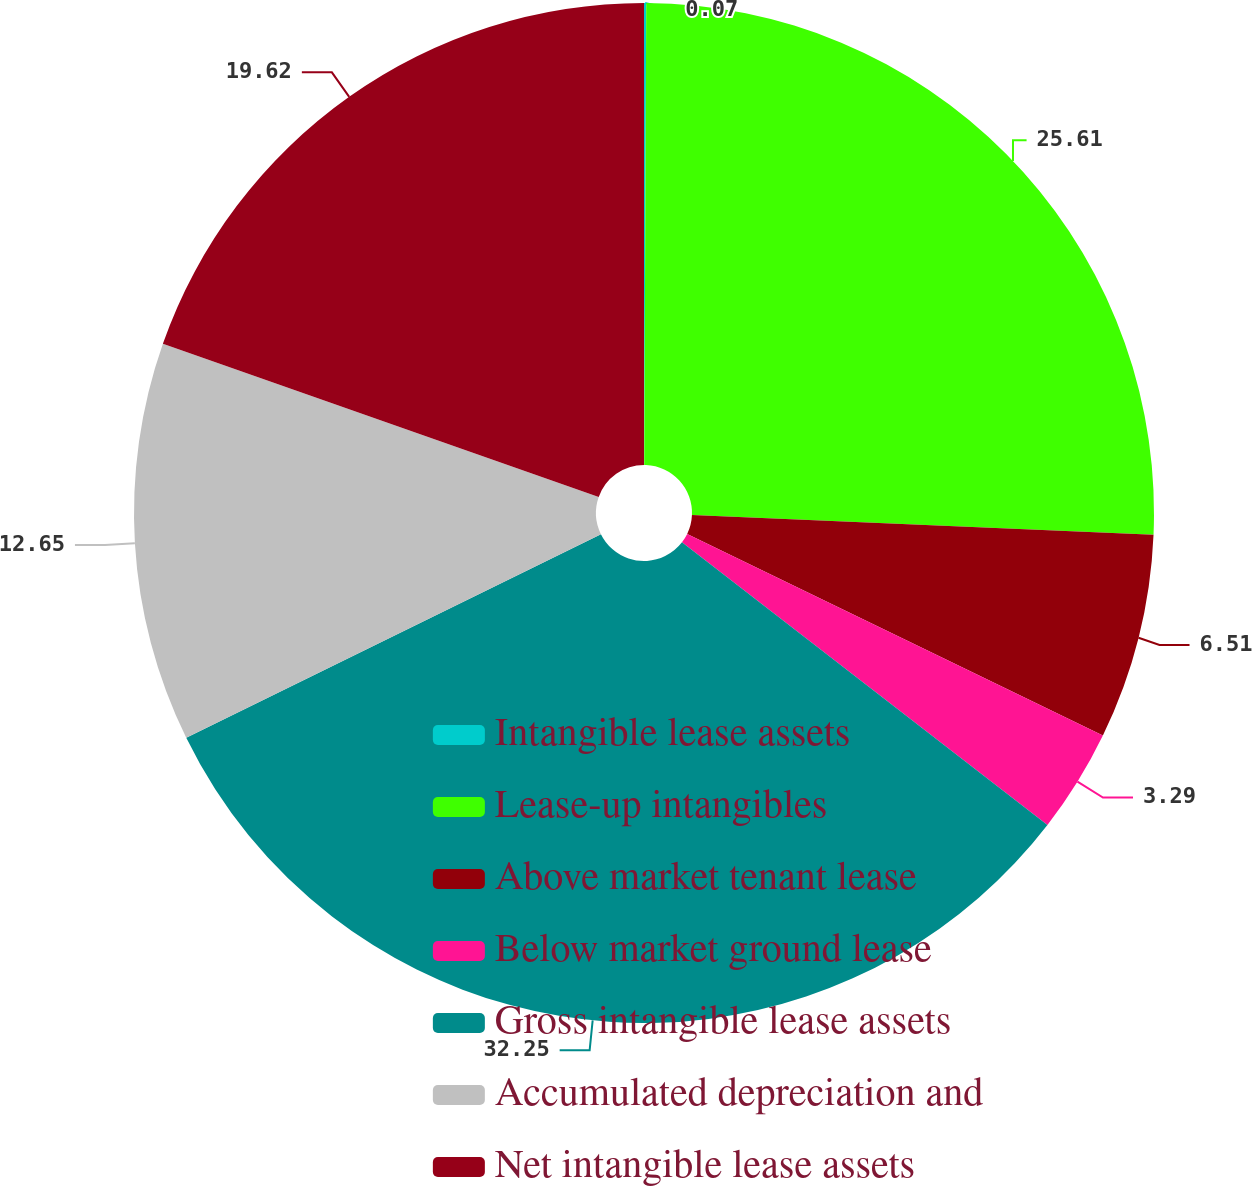Convert chart to OTSL. <chart><loc_0><loc_0><loc_500><loc_500><pie_chart><fcel>Intangible lease assets<fcel>Lease-up intangibles<fcel>Above market tenant lease<fcel>Below market ground lease<fcel>Gross intangible lease assets<fcel>Accumulated depreciation and<fcel>Net intangible lease assets<nl><fcel>0.07%<fcel>25.61%<fcel>6.51%<fcel>3.29%<fcel>32.26%<fcel>12.65%<fcel>19.62%<nl></chart> 